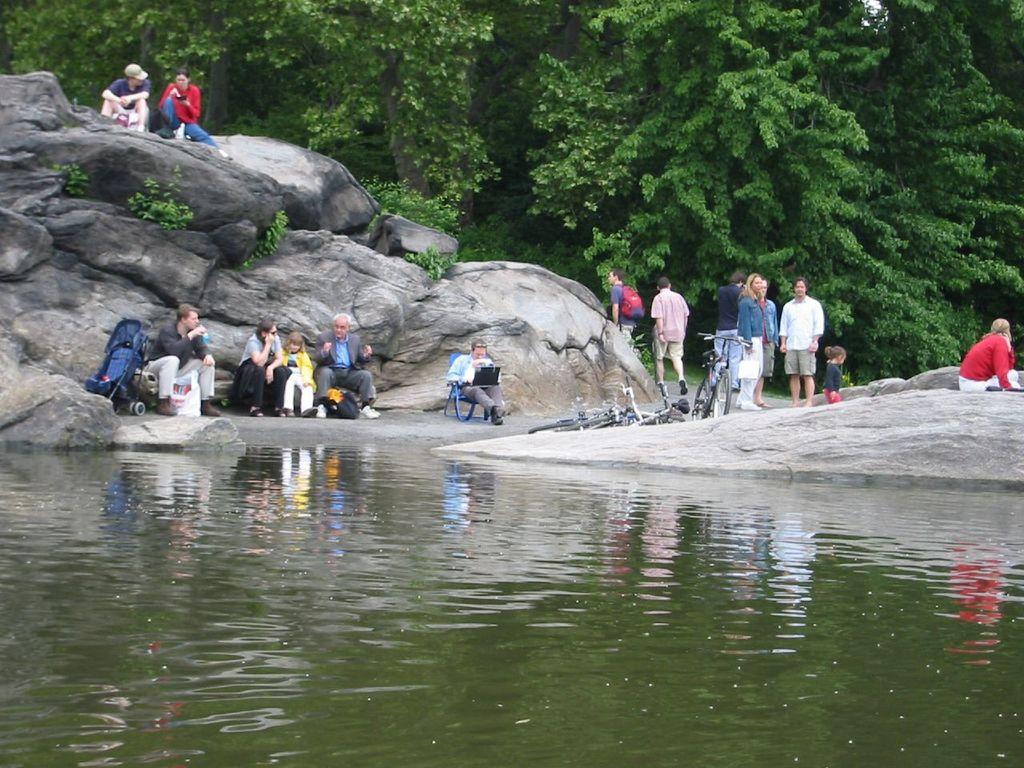What is one of the main elements present in the image? There is water in the image. What other natural elements can be seen in the image? There are rocks and plants in the image. Are there any people present in the image? Yes, there are people in the image. What type of vehicles can be seen in the image? There are bicycles in the image. What additional item is present in the image that might be used for carrying belongings? There is a stroller in the image. What objects can be seen in the image that might be used for carrying personal items? There are bags in the image. What other items can be seen in the image? There are various objects in the image. Can you describe the setting where the man is sitting in the image? There is a man sitting on a chair in the image. What can be seen in the background of the image? There are trees in the background of the image. How many clocks are visible in the image? There are no clocks present in the image. What degree of difficulty is required to ride the bicycles in the image? The image does not provide information about the difficulty level of riding the bicycles. 